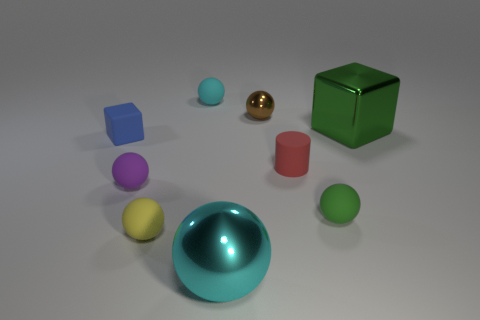Subtract all brown balls. How many balls are left? 5 Add 1 big yellow rubber cylinders. How many objects exist? 10 Subtract all tiny purple matte balls. How many balls are left? 5 Subtract all purple spheres. Subtract all brown cubes. How many spheres are left? 5 Subtract all balls. How many objects are left? 3 Subtract 0 green cylinders. How many objects are left? 9 Subtract all big yellow metallic things. Subtract all matte things. How many objects are left? 3 Add 5 cyan rubber balls. How many cyan rubber balls are left? 6 Add 8 tiny red matte cylinders. How many tiny red matte cylinders exist? 9 